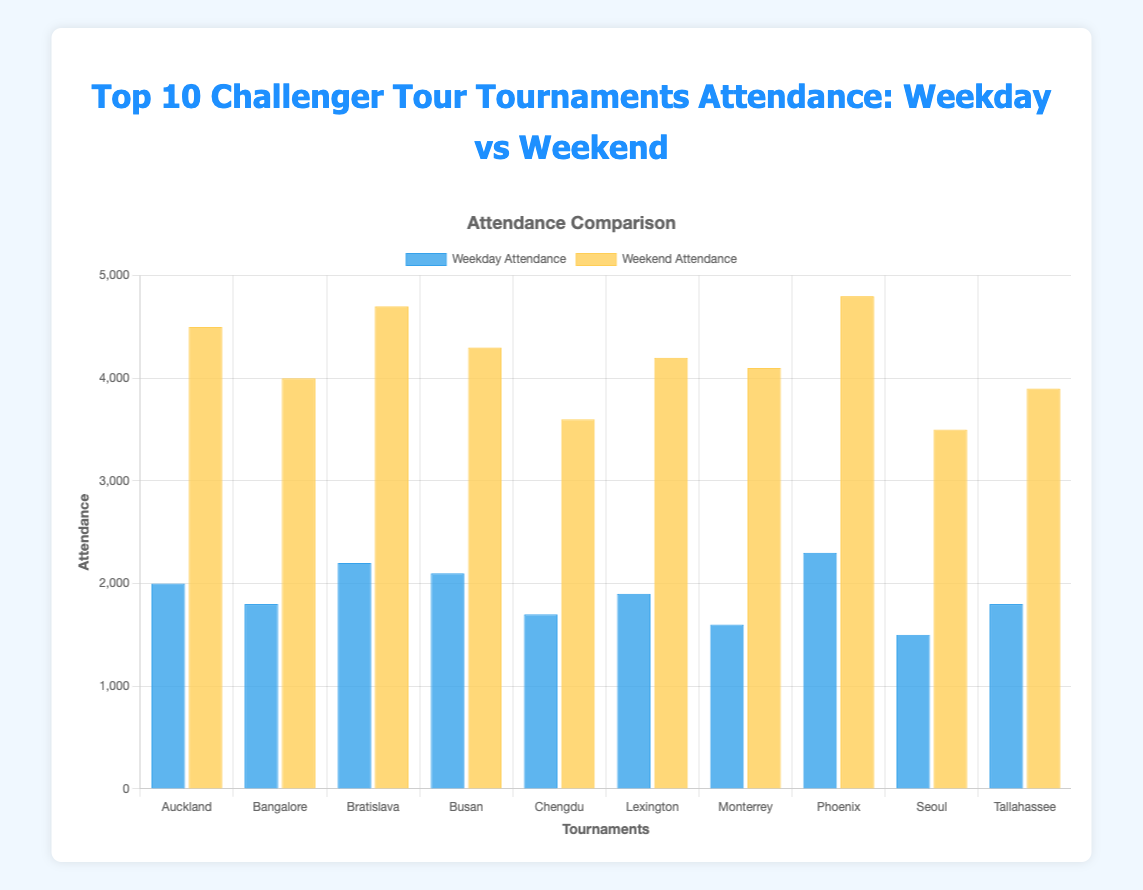Which tournament has the highest weekday attendance? To find this, look at the heights of the blue bars for each tournament. The tournament with the tallest blue bar represents the highest weekday attendance. "Phoenix Challenger" has the highest weekday attendance with 2300 attendees.
Answer: Phoenix Challenger Which tournament has a larger difference between weekend and weekday attendance? Calculate the difference between weekend and weekday attendance for each tournament by subtracting the weekday attendance from the weekend attendance, then compare these values. For Auckland Challenger, it is 4500 - 2000 = 2500, Bangalore Challenger is 4000 - 1800 = 2200, and so forth. The Bratislava Open has the largest difference with 4700 - 2200 = 2500 attendees.
Answer: Bratislava Open What is the total weekend attendance of all tournaments combined? Add the weekend attendance for all tournaments: 4500 + 4000 + 4700 + 4300 + 3600 + 4200 + 4100 + 4800 + 3500 + 3900. Sum is 41600.
Answer: 41600 On average, how many attendees are there on the weekdays across all tournaments? Sum the weekday attendance for all tournaments and divide by the number of tournaments: (2000 + 1800 + 2200 + 2100 + 1700 + 1900 + 1600 + 2300 + 1500 + 1800) / 10 = 18900 / 10 = 1890.
Answer: 1890 Which tournaments have the same number of weekend attendees? Visually identify bars with the same height for weekend attendance (yellow bars). Both Chengdu Challenger and Seoul Challenger have 3500 attendees.
Answer: Chengdu Challenger, Seoul Challenger Which tournament has the smallest difference between weekday and weekend attendance? Calculate the difference between weekend and weekday attendance for each tournament and find the smallest value. For Seoul Challenger, it is 3500 - 1500 = 2000, for Tallahassee Challenger 3900 - 1800 = 2100, and so on. The smallest difference is for Seoul Challenger with 2000.
Answer: Seoul Challenger How much more is the weekend attendance than the weekday attendance for the Monterrey Challenger? Subtract the weekday attendance from the weekend attendance for Monterrey Challenger: 4100 - 1600 = 2500.
Answer: 2500 Which tournament has the overall highest attendance, considering both weekday and weekend attendances? Sum weekday and weekend attendance for each tournament and compare. For Phoenix Challenger, it is 2300 + 4800 = 7100, the largest sum among all.
Answer: Phoenix Challenger 